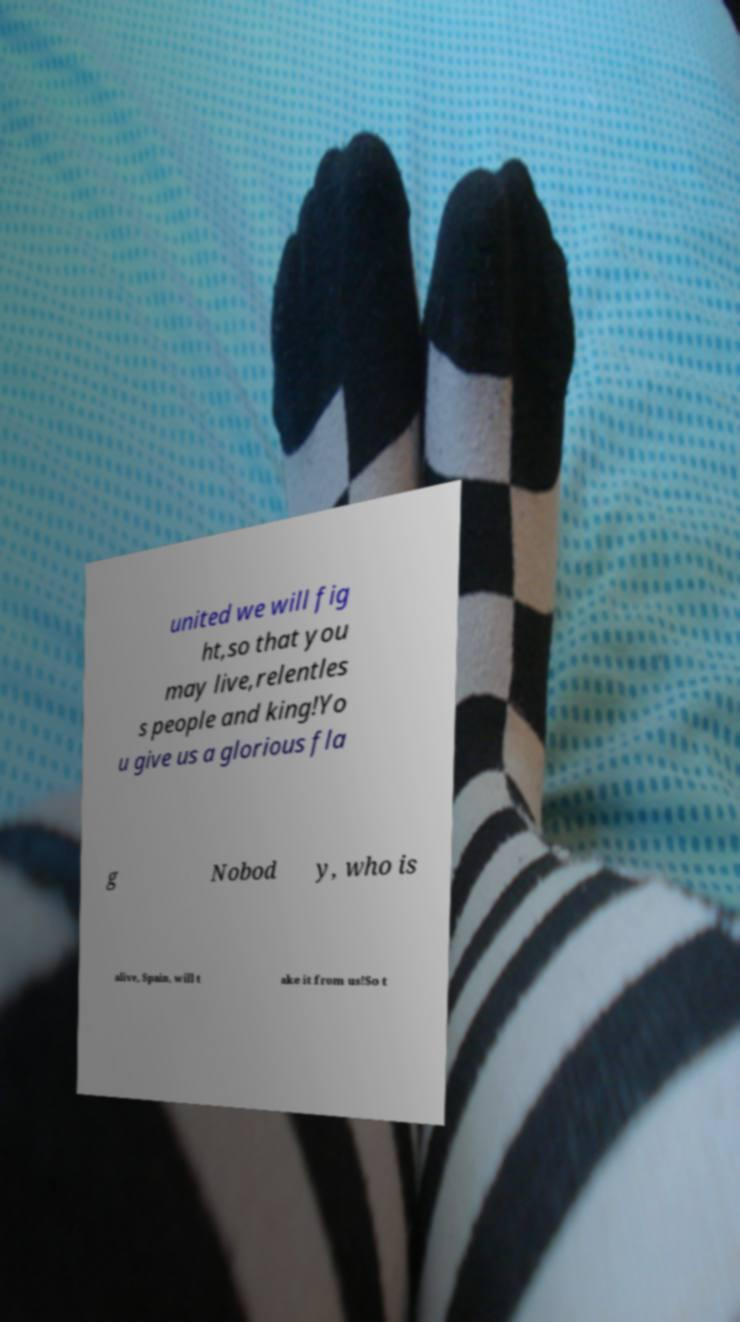Please read and relay the text visible in this image. What does it say? united we will fig ht,so that you may live,relentles s people and king!Yo u give us a glorious fla g Nobod y, who is alive, Spain, will t ake it from us!So t 